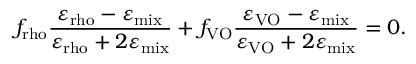Convert formula to latex. <formula><loc_0><loc_0><loc_500><loc_500>f _ { r h o } \frac { \varepsilon _ { r h o } - \varepsilon _ { m i x } } { \varepsilon _ { r h o } + 2 \varepsilon _ { m i x } } + f _ { V O } \frac { \varepsilon _ { V O } - \varepsilon _ { m i x } } { \varepsilon _ { V O } + 2 \varepsilon _ { m i x } } = 0 .</formula> 